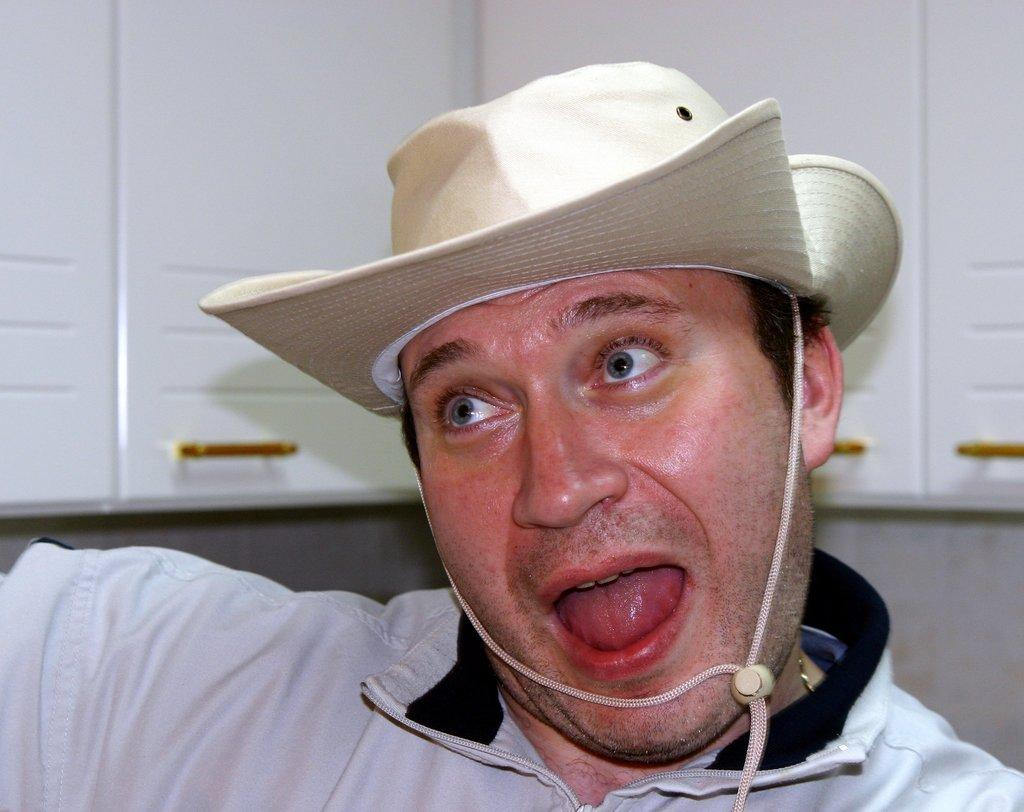Who is present in the image? There is a man in the image. What is the man wearing on his head? The man is wearing a hat. What type of clothing is the man wearing on his upper body? The man is wearing a shirt. What type of furniture is visible in the image? There are cupboards in the image. What part of the cupboards can be used to open or close the doors? There are door handles attached to the cupboard doors. What type of cent can be seen on the man's shirt in the image? There is no cent visible on the man's shirt in the image. How much salt is present on the cupboard doors in the image? There is no salt present on the cupboard doors in the image. 